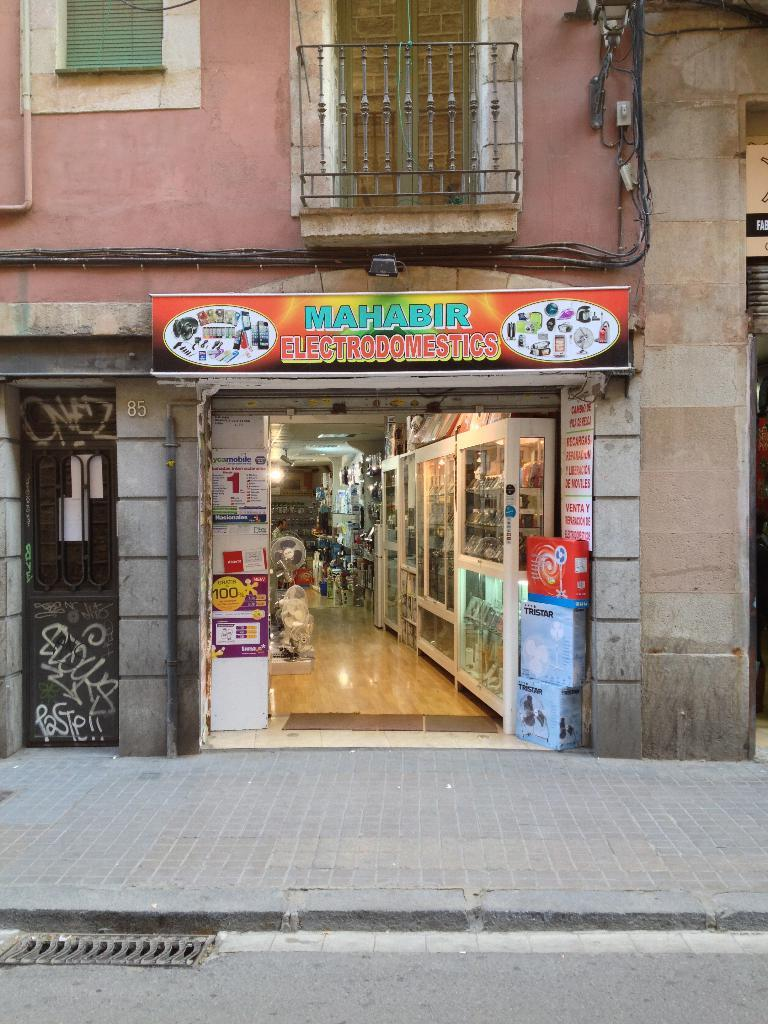<image>
Write a terse but informative summary of the picture. Mahabir electrodomestics building that is wide open on the side of the street 